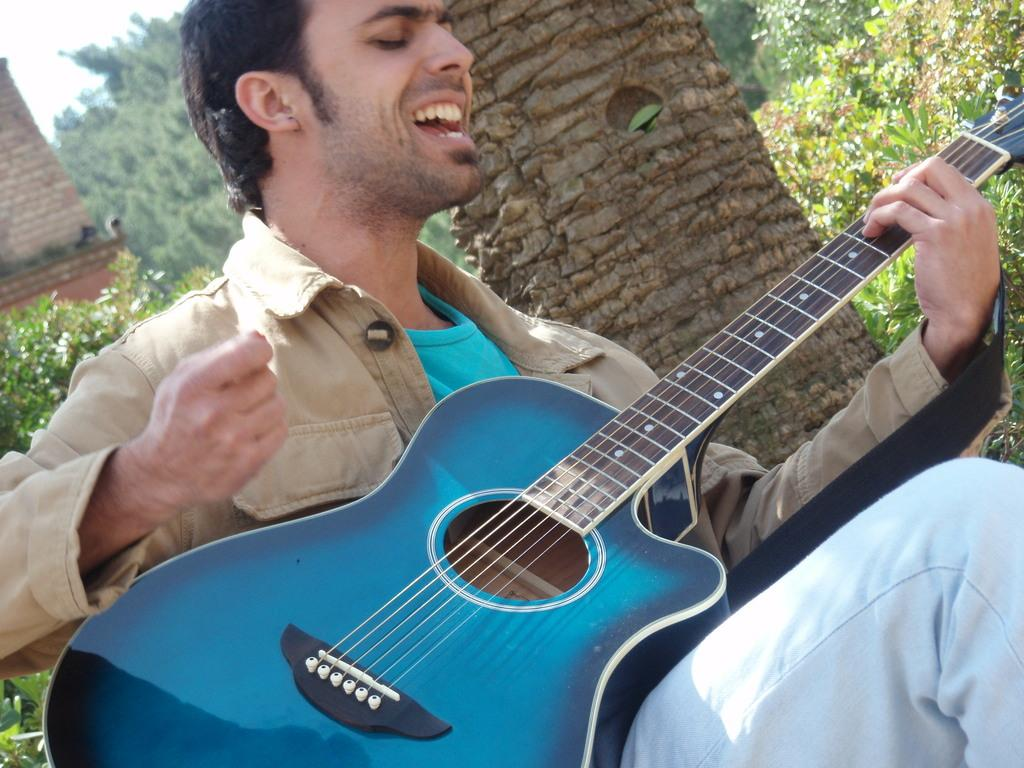What is the main subject of the image? There is a man in the image. What is the man doing in the image? The man is sitting and singing. What object is the man holding in the image? The man is holding a guitar in his hands. What can be seen in the background of the image? There is a tree in the background of the image. What type of popcorn is being served during the man's performance in the image? There is no popcorn present in the image. What time of day is the man performing in the image? The time of day cannot be determined from the image. 